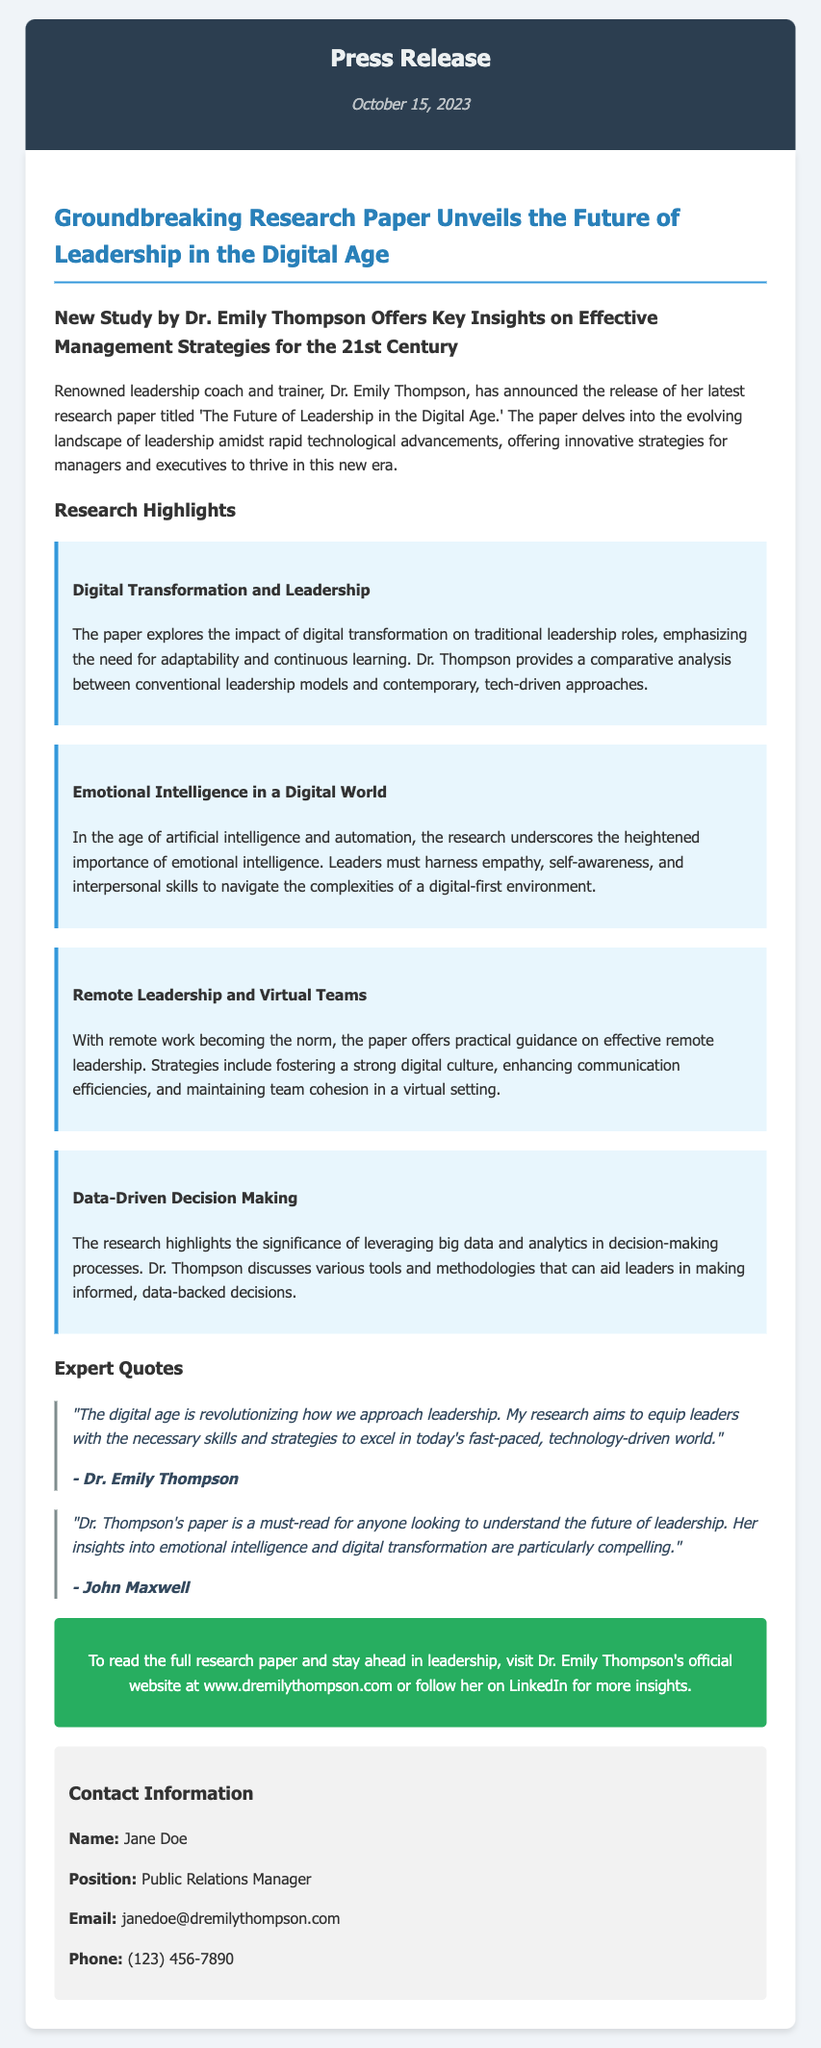What is the title of the research paper? The title of the research paper is provided in the press release, which is 'The Future of Leadership in the Digital Age.'
Answer: The Future of Leadership in the Digital Age Who is the author of the research paper? The research paper is authored by Dr. Emily Thompson, as stated in the press release.
Answer: Dr. Emily Thompson What date was the press release published? The publication date of the press release is mentioned at the top, which is October 15, 2023.
Answer: October 15, 2023 What is one of the key topics covered in the research paper? The press release lists several highlighted topics, one of which includes Digital Transformation and Leadership.
Answer: Digital Transformation and Leadership According to the research, what type of intelligence is emphasized for leaders in a digital world? The paper underscores the importance of emotional intelligence, which is specifically mentioned in the press release content.
Answer: Emotional intelligence Who provided a quote praising Dr. Thompson's paper? John Maxwell is quoted in the press release as praising Dr. Thompson's insights in her paper.
Answer: John Maxwell What is one suggested strategy for remote leadership mentioned in the paper? The press release describes fostering a strong digital culture as one of the strategies for effective remote leadership.
Answer: Fostering a strong digital culture How can readers access the full research paper? The press release provides a call to action that directs readers to Dr. Emily Thompson's official website for the full paper.
Answer: www.dremilythompson.com What is the position of the contact person mentioned in the press release? The contact person, Jane Doe, is identified in the press release as the Public Relations Manager.
Answer: Public Relations Manager 